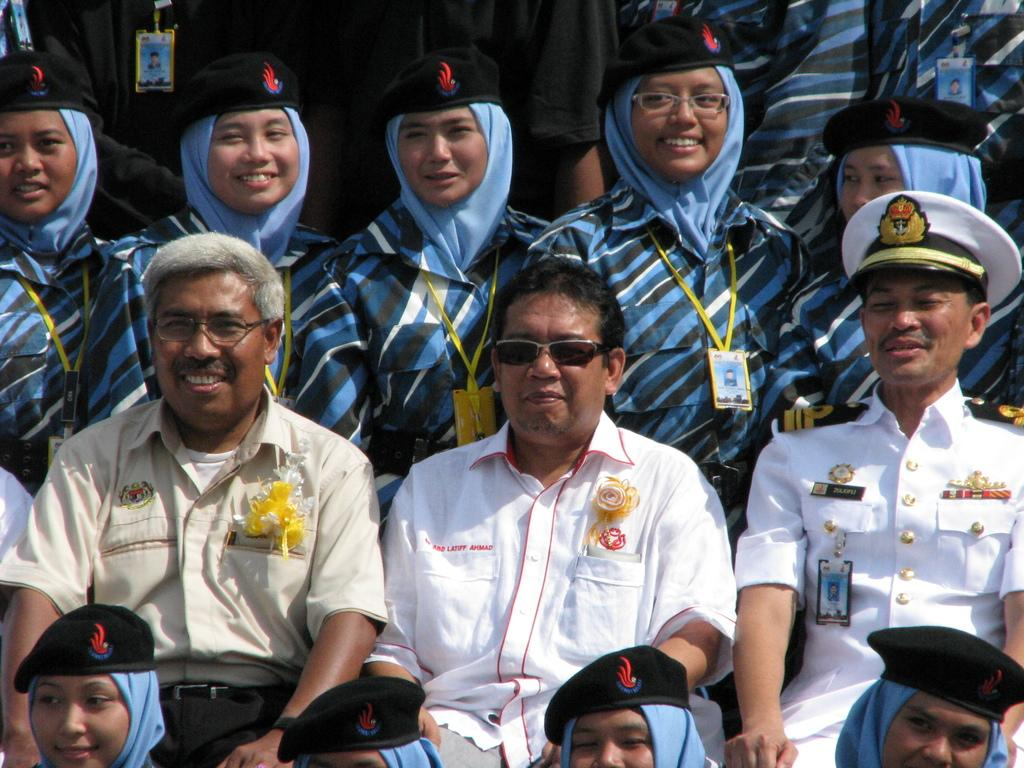How many people are in the image? There is a group of people in the image, but the exact number is not specified. What are the people in the image doing? Some people are sitting, while others are standing, and they are all smiling. What accessories can be seen on some of the people in the image? Some people are wearing caps and glasses. What type of error can be seen in the image? There is no error present in the image; it features a group of people who are smiling and wearing accessories. Can you tell me how many matches are being held by the people in the image? There is no mention of matches in the image; it features people wearing caps and glasses. 